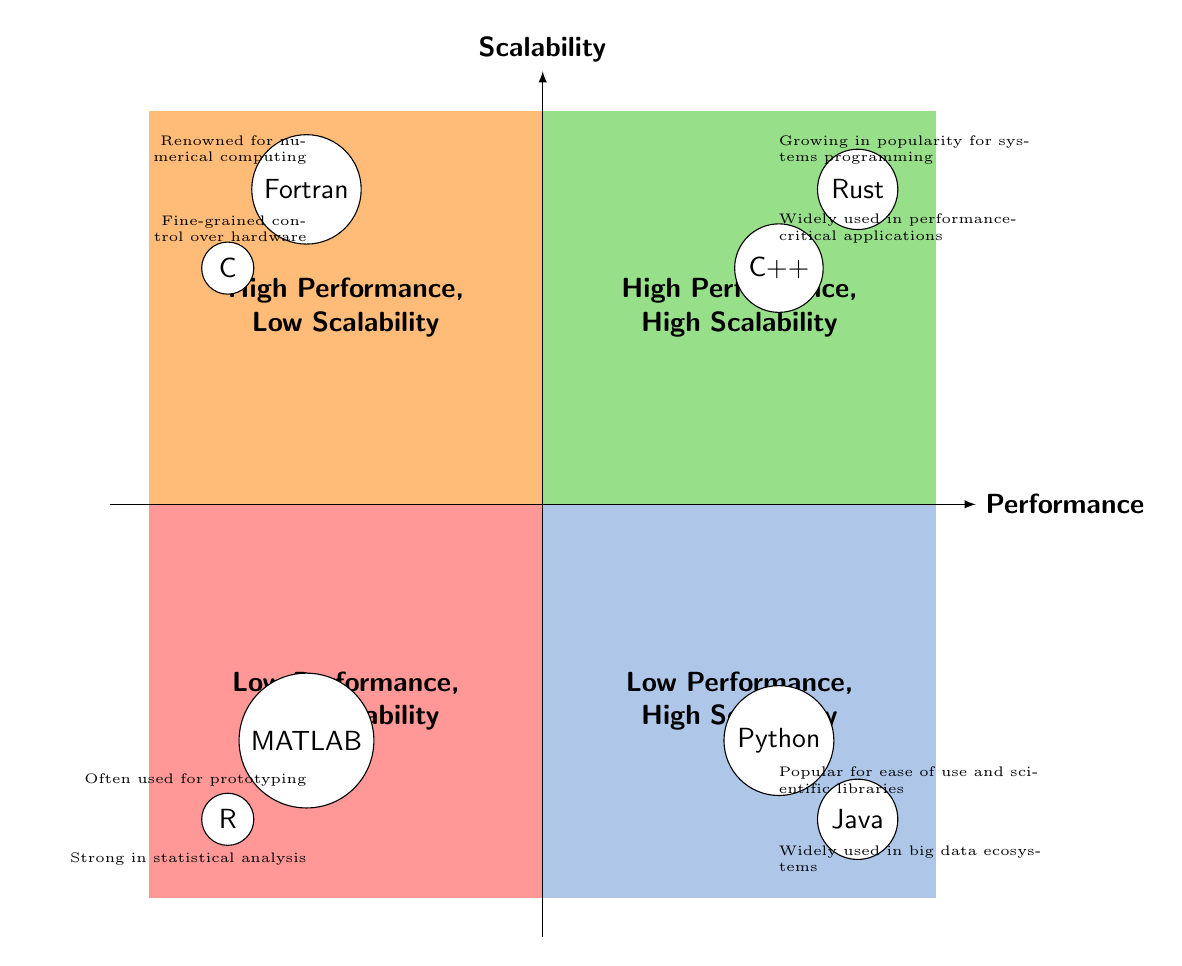What programming languages are in the High Performance, High Scalability quadrant? The languages in this quadrant are listed clearly in the diagram and they are C++ and Rust.
Answer: C++ and Rust Which quadrant contains the languages known for numerical computing? Fortran is renowned for numerical computing, and it is in the High Performance, Low Scalability quadrant according to the diagram.
Answer: High Performance, Low Scalability How many languages are placed in the Low Performance, High Scalability quadrant? The diagram shows that there are two languages: Python and Java, which are both in the Low Performance, High Scalability quadrant.
Answer: Two Which language in the diagram is specifically noted for its ease of use and scientific libraries? The diagram's usage descriptions point out that Python is popular for its ease of use and scientific libraries.
Answer: Python Which language is positioned in the Low Performance, Low Scalability quadrant and is known for statistical analysis? R is the language mentioned for statistical analysis, and according to the diagram, it is located in the Low Performance, Low Scalability quadrant.
Answer: R How does the performance scalability of Rust compare to that of Fortran? Rust is located in the High Performance, High Scalability quadrant, while Fortran is in the High Performance, Low Scalability quadrant, indicating that Rust has better scalability than Fortran.
Answer: Better scalability What is the primary usage noted for MATLAB according to the diagram? The diagram states that MATLAB is often used for prototyping and algorithm development, which is its primary noted usage.
Answer: Prototyping and algorithm development Which quadrant would you expect to find programming languages that struggle with large-scale deployment? The Low Performance, Low Scalability quadrant contains languages like MATLAB that are not ideal for large-scale deployment.
Answer: Low Performance, Low Scalability Which two languages are noted for having fine-grained control over hardware? The languages in the diagram that provide fine-grained control over hardware are C and C++.
Answer: C and C++ 